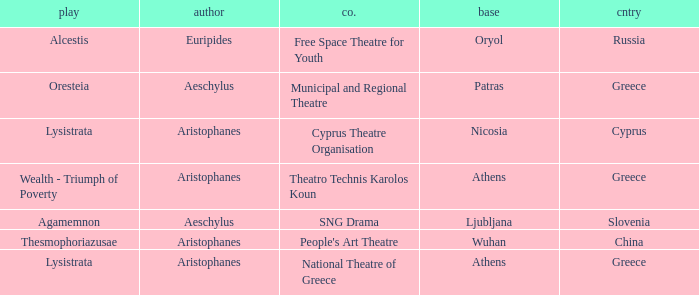What is the play when the company is national theatre of greece? Lysistrata. I'm looking to parse the entire table for insights. Could you assist me with that? {'header': ['play', 'author', 'co.', 'base', 'cntry'], 'rows': [['Alcestis', 'Euripides', 'Free Space Theatre for Youth', 'Oryol', 'Russia'], ['Oresteia', 'Aeschylus', 'Municipal and Regional Theatre', 'Patras', 'Greece'], ['Lysistrata', 'Aristophanes', 'Cyprus Theatre Organisation', 'Nicosia', 'Cyprus'], ['Wealth - Triumph of Poverty', 'Aristophanes', 'Theatro Technis Karolos Koun', 'Athens', 'Greece'], ['Agamemnon', 'Aeschylus', 'SNG Drama', 'Ljubljana', 'Slovenia'], ['Thesmophoriazusae', 'Aristophanes', "People's Art Theatre", 'Wuhan', 'China'], ['Lysistrata', 'Aristophanes', 'National Theatre of Greece', 'Athens', 'Greece']]} 